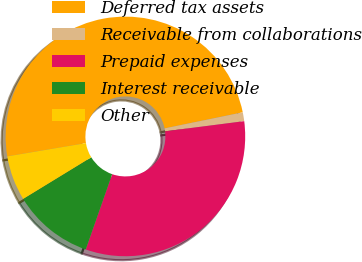<chart> <loc_0><loc_0><loc_500><loc_500><pie_chart><fcel>Deferred tax assets<fcel>Receivable from collaborations<fcel>Prepaid expenses<fcel>Interest receivable<fcel>Other<nl><fcel>49.44%<fcel>1.19%<fcel>32.4%<fcel>10.9%<fcel>6.07%<nl></chart> 